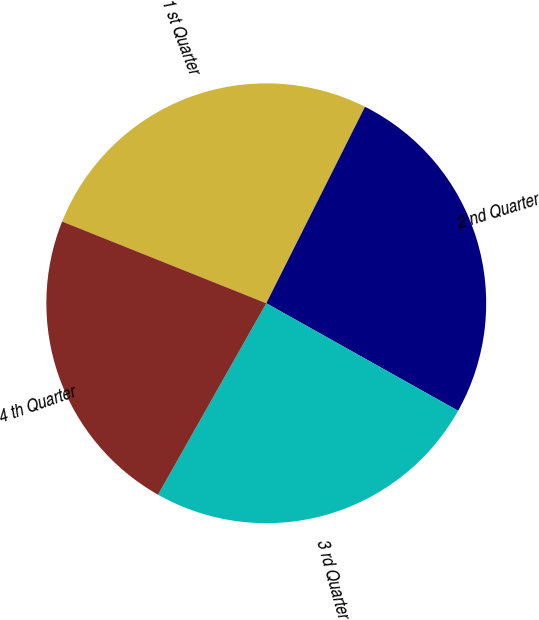<chart> <loc_0><loc_0><loc_500><loc_500><pie_chart><fcel>1 st Quarter<fcel>2 nd Quarter<fcel>3 rd Quarter<fcel>4 th Quarter<nl><fcel>26.35%<fcel>25.72%<fcel>25.06%<fcel>22.87%<nl></chart> 